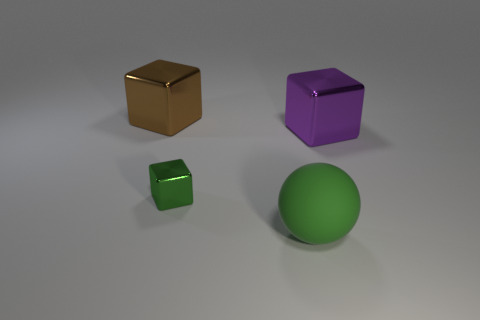Subtract all purple cubes. How many cubes are left? 2 Add 4 big blue balls. How many objects exist? 8 Subtract all blocks. How many objects are left? 1 Subtract all blue blocks. Subtract all brown balls. How many blocks are left? 3 Add 1 brown metallic blocks. How many brown metallic blocks are left? 2 Add 2 purple metal blocks. How many purple metal blocks exist? 3 Subtract 0 blue spheres. How many objects are left? 4 Subtract all purple objects. Subtract all brown shiny things. How many objects are left? 2 